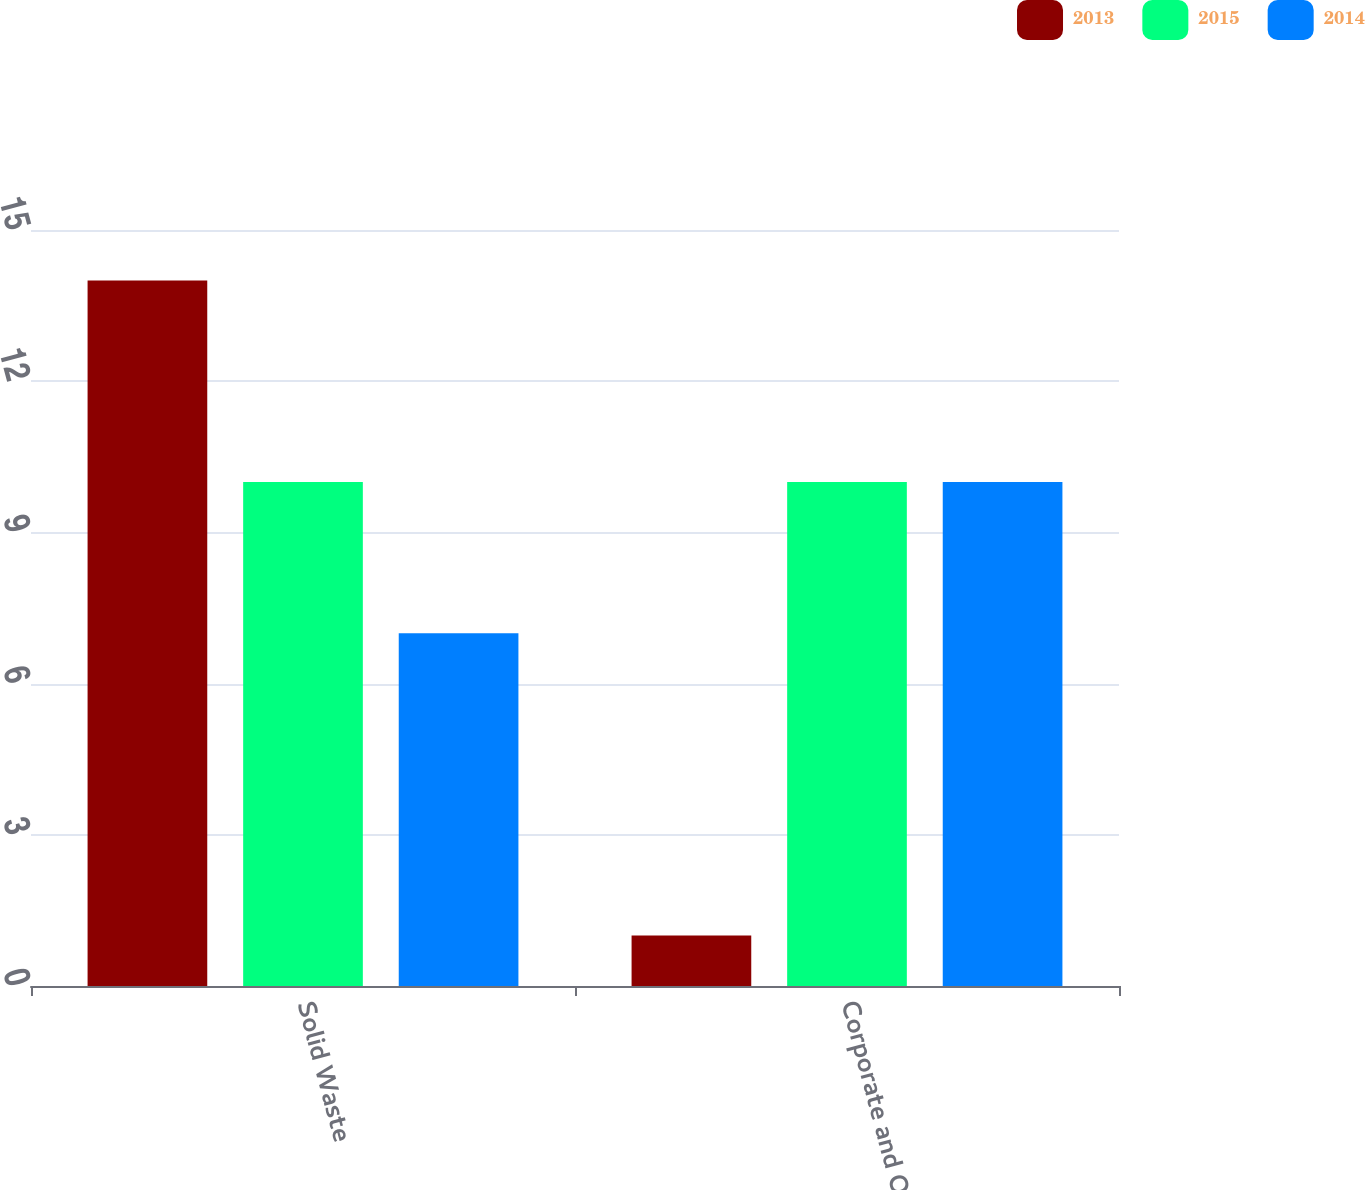<chart> <loc_0><loc_0><loc_500><loc_500><stacked_bar_chart><ecel><fcel>Solid Waste<fcel>Corporate and Other<nl><fcel>2013<fcel>14<fcel>1<nl><fcel>2015<fcel>10<fcel>10<nl><fcel>2014<fcel>7<fcel>10<nl></chart> 